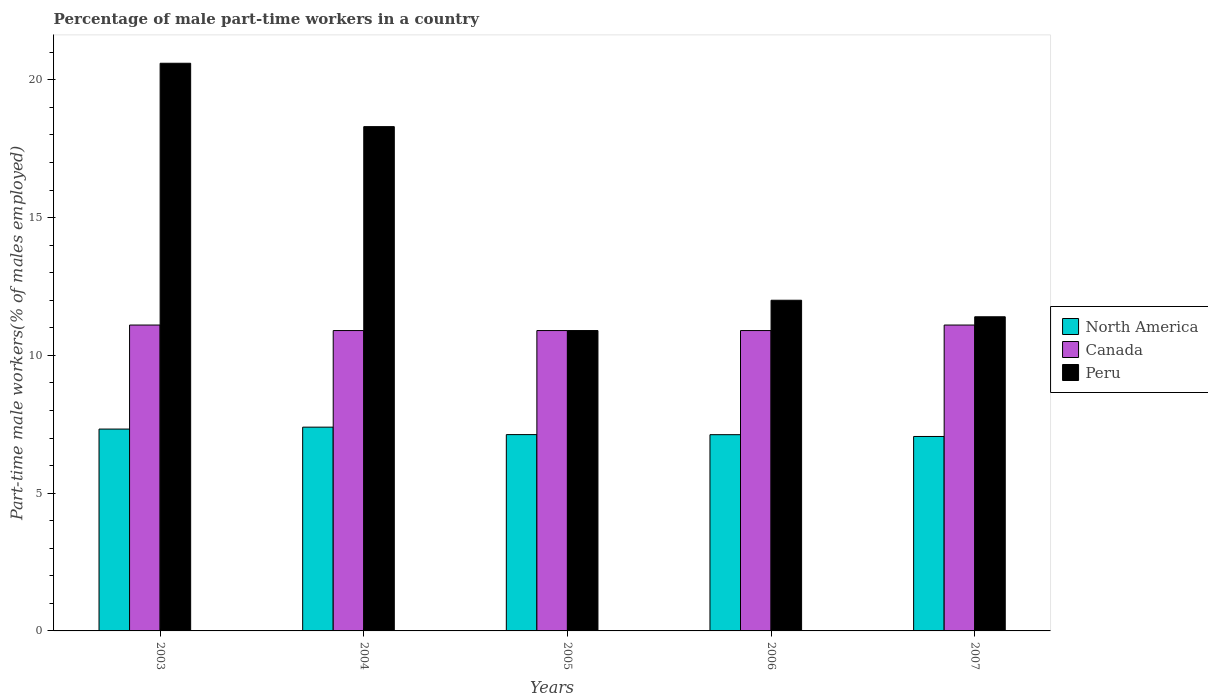How many groups of bars are there?
Provide a short and direct response. 5. Are the number of bars per tick equal to the number of legend labels?
Provide a succinct answer. Yes. How many bars are there on the 5th tick from the right?
Give a very brief answer. 3. What is the label of the 5th group of bars from the left?
Give a very brief answer. 2007. In how many cases, is the number of bars for a given year not equal to the number of legend labels?
Ensure brevity in your answer.  0. What is the percentage of male part-time workers in Canada in 2003?
Provide a short and direct response. 11.1. Across all years, what is the maximum percentage of male part-time workers in Peru?
Provide a short and direct response. 20.6. Across all years, what is the minimum percentage of male part-time workers in Canada?
Your answer should be compact. 10.9. What is the total percentage of male part-time workers in Peru in the graph?
Provide a succinct answer. 73.2. What is the difference between the percentage of male part-time workers in North America in 2003 and that in 2004?
Provide a succinct answer. -0.07. What is the difference between the percentage of male part-time workers in North America in 2007 and the percentage of male part-time workers in Peru in 2005?
Offer a terse response. -3.84. What is the average percentage of male part-time workers in Canada per year?
Your answer should be compact. 10.98. In the year 2005, what is the difference between the percentage of male part-time workers in Peru and percentage of male part-time workers in North America?
Offer a very short reply. 3.78. In how many years, is the percentage of male part-time workers in Canada greater than 6 %?
Your answer should be very brief. 5. What is the ratio of the percentage of male part-time workers in North America in 2005 to that in 2007?
Make the answer very short. 1.01. Is the percentage of male part-time workers in North America in 2006 less than that in 2007?
Provide a succinct answer. No. What is the difference between the highest and the lowest percentage of male part-time workers in Canada?
Provide a short and direct response. 0.2. In how many years, is the percentage of male part-time workers in Peru greater than the average percentage of male part-time workers in Peru taken over all years?
Keep it short and to the point. 2. Is it the case that in every year, the sum of the percentage of male part-time workers in Canada and percentage of male part-time workers in North America is greater than the percentage of male part-time workers in Peru?
Your response must be concise. No. How many bars are there?
Your answer should be compact. 15. Are the values on the major ticks of Y-axis written in scientific E-notation?
Your answer should be compact. No. Does the graph contain any zero values?
Offer a very short reply. No. Where does the legend appear in the graph?
Provide a succinct answer. Center right. How many legend labels are there?
Your answer should be very brief. 3. What is the title of the graph?
Provide a short and direct response. Percentage of male part-time workers in a country. Does "Angola" appear as one of the legend labels in the graph?
Give a very brief answer. No. What is the label or title of the X-axis?
Provide a succinct answer. Years. What is the label or title of the Y-axis?
Offer a very short reply. Part-time male workers(% of males employed). What is the Part-time male workers(% of males employed) of North America in 2003?
Offer a terse response. 7.33. What is the Part-time male workers(% of males employed) in Canada in 2003?
Offer a very short reply. 11.1. What is the Part-time male workers(% of males employed) of Peru in 2003?
Your answer should be very brief. 20.6. What is the Part-time male workers(% of males employed) of North America in 2004?
Your response must be concise. 7.39. What is the Part-time male workers(% of males employed) in Canada in 2004?
Give a very brief answer. 10.9. What is the Part-time male workers(% of males employed) of Peru in 2004?
Give a very brief answer. 18.3. What is the Part-time male workers(% of males employed) in North America in 2005?
Give a very brief answer. 7.12. What is the Part-time male workers(% of males employed) of Canada in 2005?
Ensure brevity in your answer.  10.9. What is the Part-time male workers(% of males employed) of Peru in 2005?
Offer a terse response. 10.9. What is the Part-time male workers(% of males employed) of North America in 2006?
Ensure brevity in your answer.  7.12. What is the Part-time male workers(% of males employed) in Canada in 2006?
Give a very brief answer. 10.9. What is the Part-time male workers(% of males employed) of Peru in 2006?
Offer a very short reply. 12. What is the Part-time male workers(% of males employed) in North America in 2007?
Keep it short and to the point. 7.06. What is the Part-time male workers(% of males employed) in Canada in 2007?
Offer a very short reply. 11.1. What is the Part-time male workers(% of males employed) of Peru in 2007?
Give a very brief answer. 11.4. Across all years, what is the maximum Part-time male workers(% of males employed) in North America?
Provide a succinct answer. 7.39. Across all years, what is the maximum Part-time male workers(% of males employed) in Canada?
Provide a succinct answer. 11.1. Across all years, what is the maximum Part-time male workers(% of males employed) of Peru?
Keep it short and to the point. 20.6. Across all years, what is the minimum Part-time male workers(% of males employed) in North America?
Provide a short and direct response. 7.06. Across all years, what is the minimum Part-time male workers(% of males employed) of Canada?
Ensure brevity in your answer.  10.9. Across all years, what is the minimum Part-time male workers(% of males employed) in Peru?
Make the answer very short. 10.9. What is the total Part-time male workers(% of males employed) in North America in the graph?
Provide a short and direct response. 36.02. What is the total Part-time male workers(% of males employed) of Canada in the graph?
Your answer should be very brief. 54.9. What is the total Part-time male workers(% of males employed) in Peru in the graph?
Provide a succinct answer. 73.2. What is the difference between the Part-time male workers(% of males employed) in North America in 2003 and that in 2004?
Your answer should be compact. -0.07. What is the difference between the Part-time male workers(% of males employed) of Canada in 2003 and that in 2004?
Your response must be concise. 0.2. What is the difference between the Part-time male workers(% of males employed) in North America in 2003 and that in 2005?
Give a very brief answer. 0.2. What is the difference between the Part-time male workers(% of males employed) in Peru in 2003 and that in 2005?
Keep it short and to the point. 9.7. What is the difference between the Part-time male workers(% of males employed) of North America in 2003 and that in 2006?
Keep it short and to the point. 0.2. What is the difference between the Part-time male workers(% of males employed) of Peru in 2003 and that in 2006?
Your answer should be very brief. 8.6. What is the difference between the Part-time male workers(% of males employed) in North America in 2003 and that in 2007?
Your answer should be compact. 0.27. What is the difference between the Part-time male workers(% of males employed) of Canada in 2003 and that in 2007?
Your response must be concise. 0. What is the difference between the Part-time male workers(% of males employed) of Peru in 2003 and that in 2007?
Provide a short and direct response. 9.2. What is the difference between the Part-time male workers(% of males employed) of North America in 2004 and that in 2005?
Offer a terse response. 0.27. What is the difference between the Part-time male workers(% of males employed) in Canada in 2004 and that in 2005?
Make the answer very short. 0. What is the difference between the Part-time male workers(% of males employed) in North America in 2004 and that in 2006?
Keep it short and to the point. 0.27. What is the difference between the Part-time male workers(% of males employed) of Peru in 2004 and that in 2006?
Provide a succinct answer. 6.3. What is the difference between the Part-time male workers(% of males employed) in North America in 2004 and that in 2007?
Offer a terse response. 0.34. What is the difference between the Part-time male workers(% of males employed) of Canada in 2004 and that in 2007?
Your answer should be very brief. -0.2. What is the difference between the Part-time male workers(% of males employed) in North America in 2005 and that in 2006?
Your answer should be very brief. 0. What is the difference between the Part-time male workers(% of males employed) of Peru in 2005 and that in 2006?
Your answer should be very brief. -1.1. What is the difference between the Part-time male workers(% of males employed) of North America in 2005 and that in 2007?
Keep it short and to the point. 0.07. What is the difference between the Part-time male workers(% of males employed) in Canada in 2005 and that in 2007?
Your answer should be very brief. -0.2. What is the difference between the Part-time male workers(% of males employed) of North America in 2006 and that in 2007?
Your answer should be very brief. 0.07. What is the difference between the Part-time male workers(% of males employed) in Peru in 2006 and that in 2007?
Provide a succinct answer. 0.6. What is the difference between the Part-time male workers(% of males employed) of North America in 2003 and the Part-time male workers(% of males employed) of Canada in 2004?
Provide a succinct answer. -3.57. What is the difference between the Part-time male workers(% of males employed) of North America in 2003 and the Part-time male workers(% of males employed) of Peru in 2004?
Make the answer very short. -10.97. What is the difference between the Part-time male workers(% of males employed) in North America in 2003 and the Part-time male workers(% of males employed) in Canada in 2005?
Make the answer very short. -3.57. What is the difference between the Part-time male workers(% of males employed) of North America in 2003 and the Part-time male workers(% of males employed) of Peru in 2005?
Provide a succinct answer. -3.57. What is the difference between the Part-time male workers(% of males employed) of North America in 2003 and the Part-time male workers(% of males employed) of Canada in 2006?
Keep it short and to the point. -3.57. What is the difference between the Part-time male workers(% of males employed) in North America in 2003 and the Part-time male workers(% of males employed) in Peru in 2006?
Keep it short and to the point. -4.67. What is the difference between the Part-time male workers(% of males employed) in Canada in 2003 and the Part-time male workers(% of males employed) in Peru in 2006?
Make the answer very short. -0.9. What is the difference between the Part-time male workers(% of males employed) in North America in 2003 and the Part-time male workers(% of males employed) in Canada in 2007?
Make the answer very short. -3.77. What is the difference between the Part-time male workers(% of males employed) in North America in 2003 and the Part-time male workers(% of males employed) in Peru in 2007?
Offer a very short reply. -4.07. What is the difference between the Part-time male workers(% of males employed) in Canada in 2003 and the Part-time male workers(% of males employed) in Peru in 2007?
Offer a terse response. -0.3. What is the difference between the Part-time male workers(% of males employed) of North America in 2004 and the Part-time male workers(% of males employed) of Canada in 2005?
Keep it short and to the point. -3.51. What is the difference between the Part-time male workers(% of males employed) in North America in 2004 and the Part-time male workers(% of males employed) in Peru in 2005?
Give a very brief answer. -3.51. What is the difference between the Part-time male workers(% of males employed) in Canada in 2004 and the Part-time male workers(% of males employed) in Peru in 2005?
Your response must be concise. 0. What is the difference between the Part-time male workers(% of males employed) in North America in 2004 and the Part-time male workers(% of males employed) in Canada in 2006?
Your response must be concise. -3.51. What is the difference between the Part-time male workers(% of males employed) in North America in 2004 and the Part-time male workers(% of males employed) in Peru in 2006?
Give a very brief answer. -4.61. What is the difference between the Part-time male workers(% of males employed) of North America in 2004 and the Part-time male workers(% of males employed) of Canada in 2007?
Offer a very short reply. -3.71. What is the difference between the Part-time male workers(% of males employed) in North America in 2004 and the Part-time male workers(% of males employed) in Peru in 2007?
Your answer should be very brief. -4.01. What is the difference between the Part-time male workers(% of males employed) of North America in 2005 and the Part-time male workers(% of males employed) of Canada in 2006?
Your answer should be very brief. -3.78. What is the difference between the Part-time male workers(% of males employed) of North America in 2005 and the Part-time male workers(% of males employed) of Peru in 2006?
Ensure brevity in your answer.  -4.88. What is the difference between the Part-time male workers(% of males employed) in North America in 2005 and the Part-time male workers(% of males employed) in Canada in 2007?
Your answer should be compact. -3.98. What is the difference between the Part-time male workers(% of males employed) in North America in 2005 and the Part-time male workers(% of males employed) in Peru in 2007?
Provide a short and direct response. -4.28. What is the difference between the Part-time male workers(% of males employed) of Canada in 2005 and the Part-time male workers(% of males employed) of Peru in 2007?
Offer a very short reply. -0.5. What is the difference between the Part-time male workers(% of males employed) in North America in 2006 and the Part-time male workers(% of males employed) in Canada in 2007?
Give a very brief answer. -3.98. What is the difference between the Part-time male workers(% of males employed) of North America in 2006 and the Part-time male workers(% of males employed) of Peru in 2007?
Your response must be concise. -4.28. What is the difference between the Part-time male workers(% of males employed) of Canada in 2006 and the Part-time male workers(% of males employed) of Peru in 2007?
Offer a terse response. -0.5. What is the average Part-time male workers(% of males employed) in North America per year?
Provide a succinct answer. 7.2. What is the average Part-time male workers(% of males employed) in Canada per year?
Make the answer very short. 10.98. What is the average Part-time male workers(% of males employed) in Peru per year?
Provide a short and direct response. 14.64. In the year 2003, what is the difference between the Part-time male workers(% of males employed) of North America and Part-time male workers(% of males employed) of Canada?
Offer a terse response. -3.77. In the year 2003, what is the difference between the Part-time male workers(% of males employed) in North America and Part-time male workers(% of males employed) in Peru?
Offer a terse response. -13.27. In the year 2004, what is the difference between the Part-time male workers(% of males employed) in North America and Part-time male workers(% of males employed) in Canada?
Make the answer very short. -3.51. In the year 2004, what is the difference between the Part-time male workers(% of males employed) of North America and Part-time male workers(% of males employed) of Peru?
Provide a short and direct response. -10.91. In the year 2005, what is the difference between the Part-time male workers(% of males employed) of North America and Part-time male workers(% of males employed) of Canada?
Keep it short and to the point. -3.78. In the year 2005, what is the difference between the Part-time male workers(% of males employed) in North America and Part-time male workers(% of males employed) in Peru?
Keep it short and to the point. -3.78. In the year 2005, what is the difference between the Part-time male workers(% of males employed) in Canada and Part-time male workers(% of males employed) in Peru?
Offer a very short reply. 0. In the year 2006, what is the difference between the Part-time male workers(% of males employed) of North America and Part-time male workers(% of males employed) of Canada?
Make the answer very short. -3.78. In the year 2006, what is the difference between the Part-time male workers(% of males employed) in North America and Part-time male workers(% of males employed) in Peru?
Provide a short and direct response. -4.88. In the year 2006, what is the difference between the Part-time male workers(% of males employed) of Canada and Part-time male workers(% of males employed) of Peru?
Give a very brief answer. -1.1. In the year 2007, what is the difference between the Part-time male workers(% of males employed) in North America and Part-time male workers(% of males employed) in Canada?
Your answer should be very brief. -4.04. In the year 2007, what is the difference between the Part-time male workers(% of males employed) of North America and Part-time male workers(% of males employed) of Peru?
Offer a very short reply. -4.34. In the year 2007, what is the difference between the Part-time male workers(% of males employed) of Canada and Part-time male workers(% of males employed) of Peru?
Offer a terse response. -0.3. What is the ratio of the Part-time male workers(% of males employed) of North America in 2003 to that in 2004?
Your answer should be very brief. 0.99. What is the ratio of the Part-time male workers(% of males employed) of Canada in 2003 to that in 2004?
Provide a short and direct response. 1.02. What is the ratio of the Part-time male workers(% of males employed) of Peru in 2003 to that in 2004?
Your answer should be compact. 1.13. What is the ratio of the Part-time male workers(% of males employed) of North America in 2003 to that in 2005?
Your response must be concise. 1.03. What is the ratio of the Part-time male workers(% of males employed) of Canada in 2003 to that in 2005?
Ensure brevity in your answer.  1.02. What is the ratio of the Part-time male workers(% of males employed) in Peru in 2003 to that in 2005?
Provide a short and direct response. 1.89. What is the ratio of the Part-time male workers(% of males employed) of North America in 2003 to that in 2006?
Your answer should be compact. 1.03. What is the ratio of the Part-time male workers(% of males employed) of Canada in 2003 to that in 2006?
Provide a succinct answer. 1.02. What is the ratio of the Part-time male workers(% of males employed) of Peru in 2003 to that in 2006?
Your response must be concise. 1.72. What is the ratio of the Part-time male workers(% of males employed) of North America in 2003 to that in 2007?
Your answer should be compact. 1.04. What is the ratio of the Part-time male workers(% of males employed) of Canada in 2003 to that in 2007?
Offer a terse response. 1. What is the ratio of the Part-time male workers(% of males employed) in Peru in 2003 to that in 2007?
Ensure brevity in your answer.  1.81. What is the ratio of the Part-time male workers(% of males employed) of North America in 2004 to that in 2005?
Provide a short and direct response. 1.04. What is the ratio of the Part-time male workers(% of males employed) of Peru in 2004 to that in 2005?
Make the answer very short. 1.68. What is the ratio of the Part-time male workers(% of males employed) in North America in 2004 to that in 2006?
Your answer should be compact. 1.04. What is the ratio of the Part-time male workers(% of males employed) of Canada in 2004 to that in 2006?
Your answer should be very brief. 1. What is the ratio of the Part-time male workers(% of males employed) in Peru in 2004 to that in 2006?
Provide a succinct answer. 1.52. What is the ratio of the Part-time male workers(% of males employed) of North America in 2004 to that in 2007?
Give a very brief answer. 1.05. What is the ratio of the Part-time male workers(% of males employed) of Canada in 2004 to that in 2007?
Make the answer very short. 0.98. What is the ratio of the Part-time male workers(% of males employed) of Peru in 2004 to that in 2007?
Provide a short and direct response. 1.61. What is the ratio of the Part-time male workers(% of males employed) in North America in 2005 to that in 2006?
Make the answer very short. 1. What is the ratio of the Part-time male workers(% of males employed) of Peru in 2005 to that in 2006?
Make the answer very short. 0.91. What is the ratio of the Part-time male workers(% of males employed) of North America in 2005 to that in 2007?
Provide a short and direct response. 1.01. What is the ratio of the Part-time male workers(% of males employed) in Peru in 2005 to that in 2007?
Offer a very short reply. 0.96. What is the ratio of the Part-time male workers(% of males employed) in North America in 2006 to that in 2007?
Provide a short and direct response. 1.01. What is the ratio of the Part-time male workers(% of males employed) of Peru in 2006 to that in 2007?
Keep it short and to the point. 1.05. What is the difference between the highest and the second highest Part-time male workers(% of males employed) of North America?
Your answer should be very brief. 0.07. What is the difference between the highest and the second highest Part-time male workers(% of males employed) in Canada?
Provide a succinct answer. 0. What is the difference between the highest and the lowest Part-time male workers(% of males employed) of North America?
Keep it short and to the point. 0.34. 